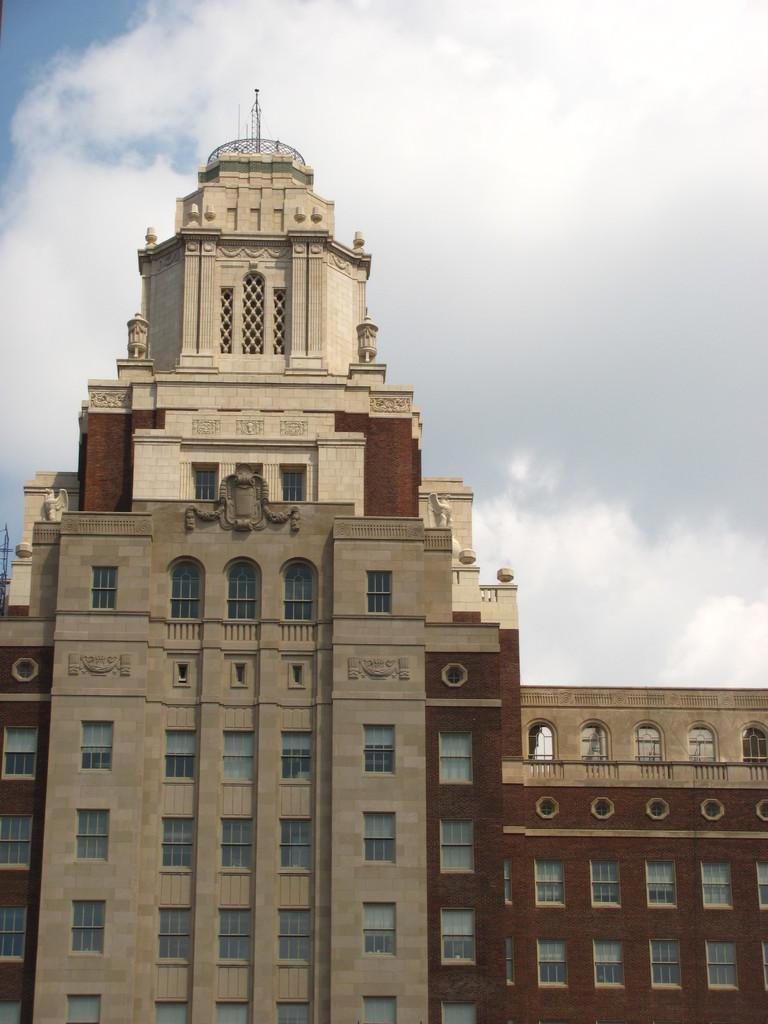Please provide a concise description of this image. In the image there is a huge building, it has a lot of windows and there are some carvings to the walls of the building. 